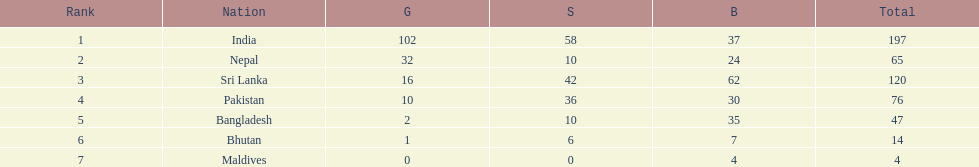What was the only nation to win less than 10 medals total? Maldives. 